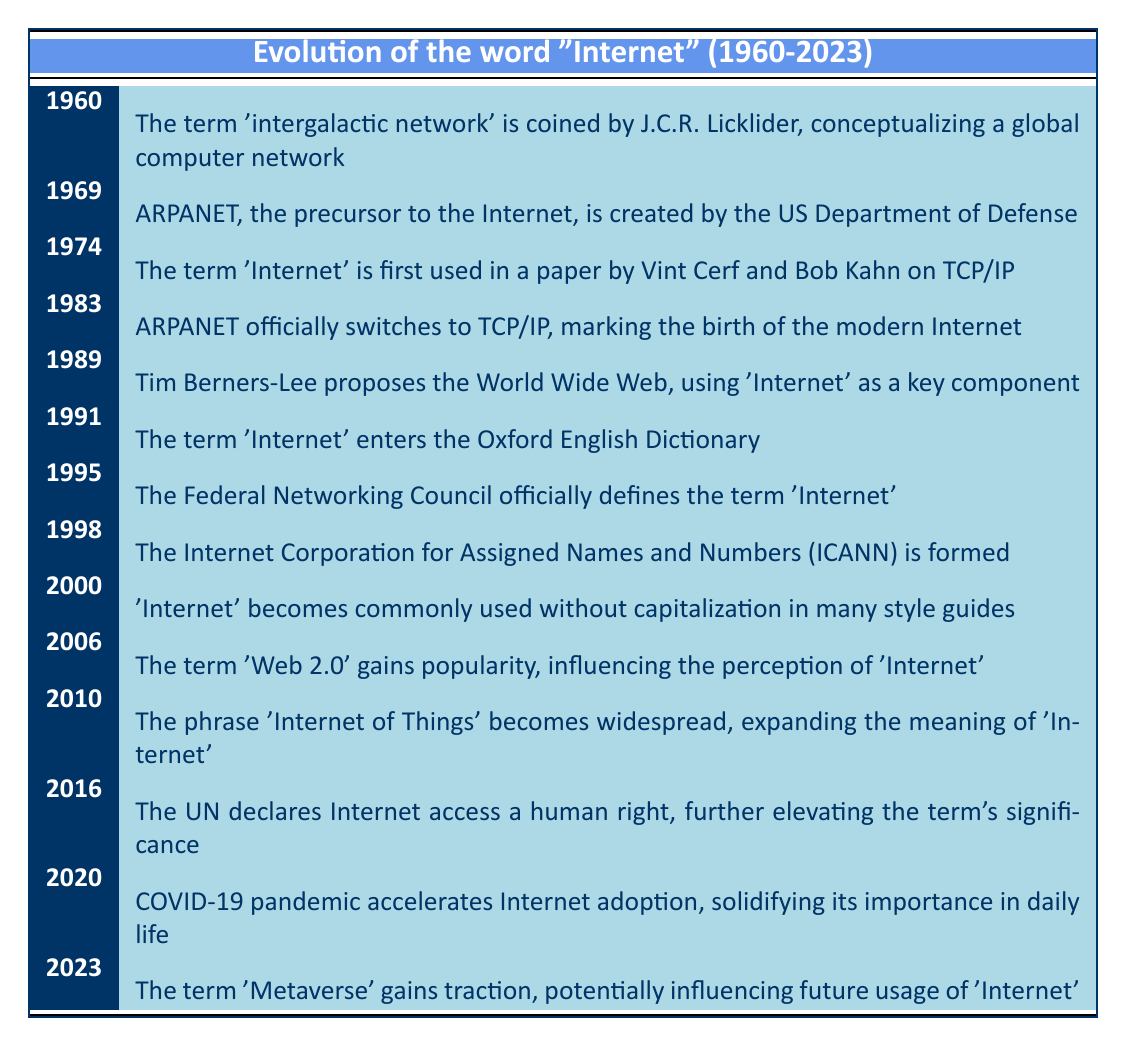What year was the term 'Internet' first used? The table indicates that the term 'Internet' was first used in a paper by Vint Cerf and Bob Kahn on TCP/IP in the year 1974.
Answer: 1974 Which event marks the birth of the modern Internet? According to the table, the event that marks the birth of the modern Internet is when ARPANET officially switched to TCP/IP in 1983.
Answer: ARPANET officially switches to TCP/IP in 1983 What was proposed by Tim Berners-Lee in 1989? The table states that in 1989, Tim Berners-Lee proposed the World Wide Web, which used 'Internet' as a key component.
Answer: The World Wide Web How many years are there between the first use of 'Internet' and its entry into the Oxford English Dictionary? The first use of 'Internet' was in 1974 and it entered the Oxford English Dictionary in 1991, which is 1991 - 1974 = 17 years.
Answer: 17 years Was the term 'Internet' defined by the Federal Networking Council? Yes, the table confirms that in 1995, the Federal Networking Council officially defined the term 'Internet'.
Answer: Yes What influence did 'Web 2.0' have on the perception of 'Internet'? The table indicates that in 2006, the term 'Web 2.0' gained popularity, which influenced the perception of 'Internet'. This implies that 'Web 2.0' altered how people viewed the Internet concept.
Answer: Influence of perception List the key components that contributed to the significance of 'Internet' from 1983 to 2023. From the table, in 1983 ARPANET switched to TCP/IP, marking the birth of the modern Internet. In 2016, the UN declared internet access a human right, and in 2020, COVID-19 accelerated internet adoption. Combined, these events contributed to the increasing significance of the term 'Internet'.
Answer: ARPANET switch to TCP/IP, UN human rights declaration, COVID-19 influence In what context did the term 'Internet' gain traction in 2023? According to the table, in 2023, the term 'Metaverse' gained traction, indicating that it may influence the future usage of the term 'Internet'. This suggests a shift in focus towards integrated digital realities.
Answer: Metaverse influence 